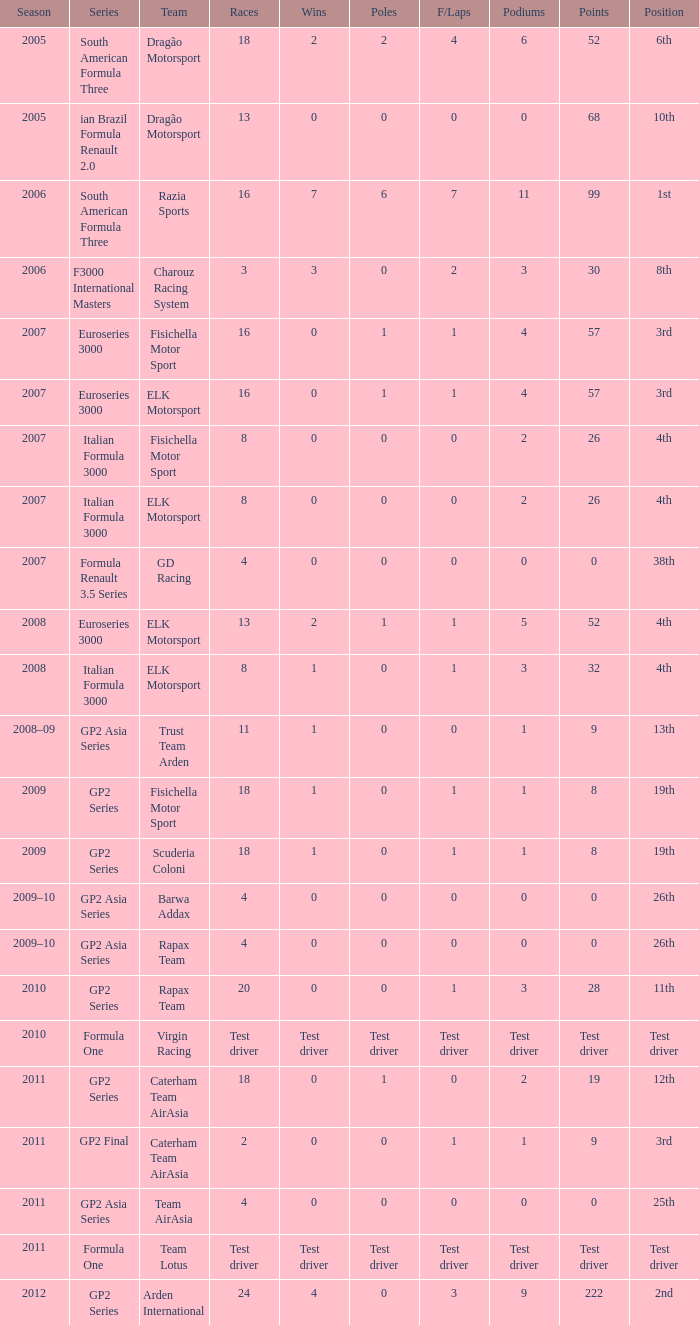How many events did he engage in when he earned 8 points in that year? 18, 18. 